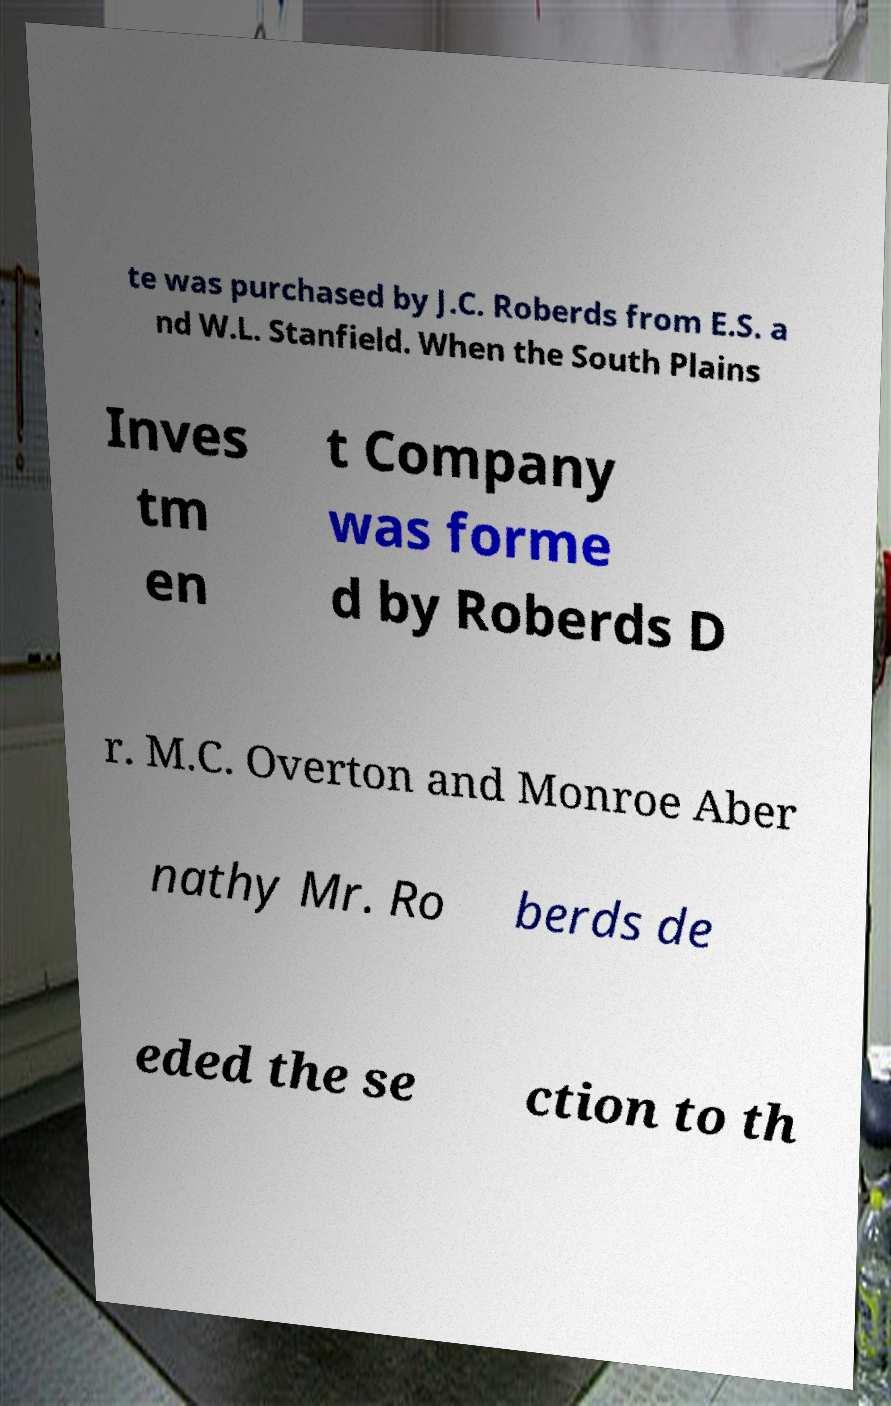Could you extract and type out the text from this image? te was purchased by J.C. Roberds from E.S. a nd W.L. Stanfield. When the South Plains Inves tm en t Company was forme d by Roberds D r. M.C. Overton and Monroe Aber nathy Mr. Ro berds de eded the se ction to th 